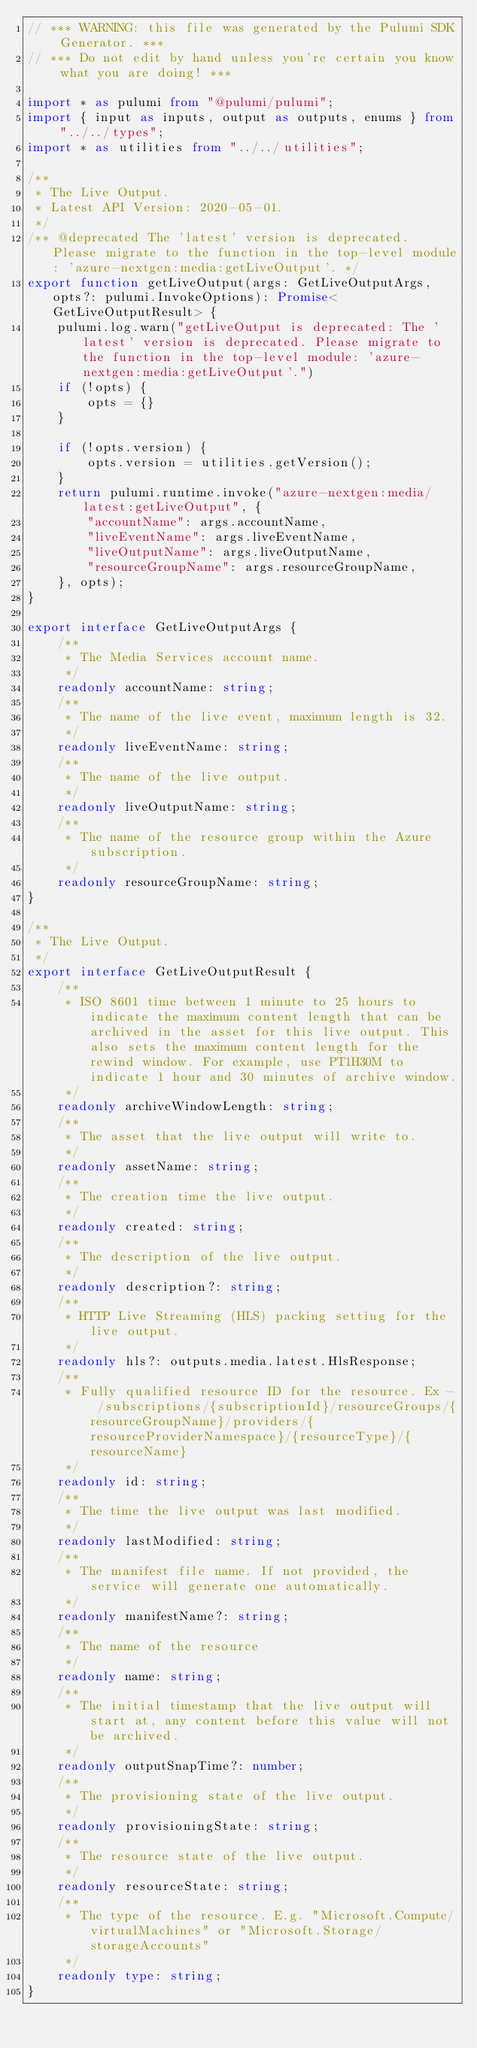Convert code to text. <code><loc_0><loc_0><loc_500><loc_500><_TypeScript_>// *** WARNING: this file was generated by the Pulumi SDK Generator. ***
// *** Do not edit by hand unless you're certain you know what you are doing! ***

import * as pulumi from "@pulumi/pulumi";
import { input as inputs, output as outputs, enums } from "../../types";
import * as utilities from "../../utilities";

/**
 * The Live Output.
 * Latest API Version: 2020-05-01.
 */
/** @deprecated The 'latest' version is deprecated. Please migrate to the function in the top-level module: 'azure-nextgen:media:getLiveOutput'. */
export function getLiveOutput(args: GetLiveOutputArgs, opts?: pulumi.InvokeOptions): Promise<GetLiveOutputResult> {
    pulumi.log.warn("getLiveOutput is deprecated: The 'latest' version is deprecated. Please migrate to the function in the top-level module: 'azure-nextgen:media:getLiveOutput'.")
    if (!opts) {
        opts = {}
    }

    if (!opts.version) {
        opts.version = utilities.getVersion();
    }
    return pulumi.runtime.invoke("azure-nextgen:media/latest:getLiveOutput", {
        "accountName": args.accountName,
        "liveEventName": args.liveEventName,
        "liveOutputName": args.liveOutputName,
        "resourceGroupName": args.resourceGroupName,
    }, opts);
}

export interface GetLiveOutputArgs {
    /**
     * The Media Services account name.
     */
    readonly accountName: string;
    /**
     * The name of the live event, maximum length is 32.
     */
    readonly liveEventName: string;
    /**
     * The name of the live output.
     */
    readonly liveOutputName: string;
    /**
     * The name of the resource group within the Azure subscription.
     */
    readonly resourceGroupName: string;
}

/**
 * The Live Output.
 */
export interface GetLiveOutputResult {
    /**
     * ISO 8601 time between 1 minute to 25 hours to indicate the maximum content length that can be archived in the asset for this live output. This also sets the maximum content length for the rewind window. For example, use PT1H30M to indicate 1 hour and 30 minutes of archive window.
     */
    readonly archiveWindowLength: string;
    /**
     * The asset that the live output will write to.
     */
    readonly assetName: string;
    /**
     * The creation time the live output.
     */
    readonly created: string;
    /**
     * The description of the live output.
     */
    readonly description?: string;
    /**
     * HTTP Live Streaming (HLS) packing setting for the live output.
     */
    readonly hls?: outputs.media.latest.HlsResponse;
    /**
     * Fully qualified resource ID for the resource. Ex - /subscriptions/{subscriptionId}/resourceGroups/{resourceGroupName}/providers/{resourceProviderNamespace}/{resourceType}/{resourceName}
     */
    readonly id: string;
    /**
     * The time the live output was last modified.
     */
    readonly lastModified: string;
    /**
     * The manifest file name. If not provided, the service will generate one automatically.
     */
    readonly manifestName?: string;
    /**
     * The name of the resource
     */
    readonly name: string;
    /**
     * The initial timestamp that the live output will start at, any content before this value will not be archived.
     */
    readonly outputSnapTime?: number;
    /**
     * The provisioning state of the live output.
     */
    readonly provisioningState: string;
    /**
     * The resource state of the live output.
     */
    readonly resourceState: string;
    /**
     * The type of the resource. E.g. "Microsoft.Compute/virtualMachines" or "Microsoft.Storage/storageAccounts"
     */
    readonly type: string;
}
</code> 